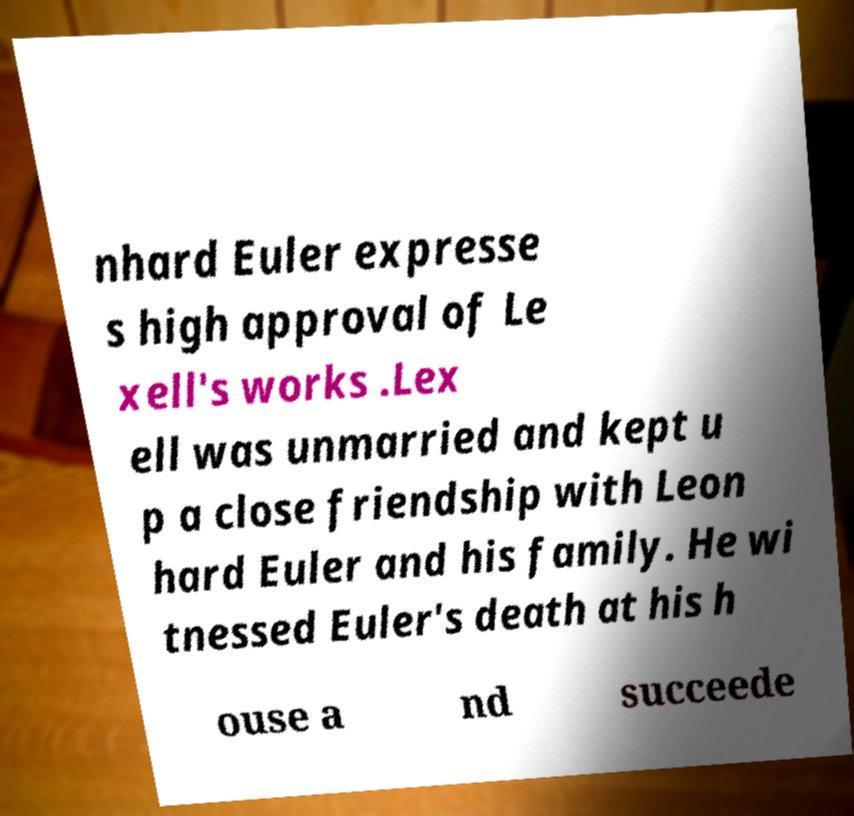Please identify and transcribe the text found in this image. nhard Euler expresse s high approval of Le xell's works .Lex ell was unmarried and kept u p a close friendship with Leon hard Euler and his family. He wi tnessed Euler's death at his h ouse a nd succeede 